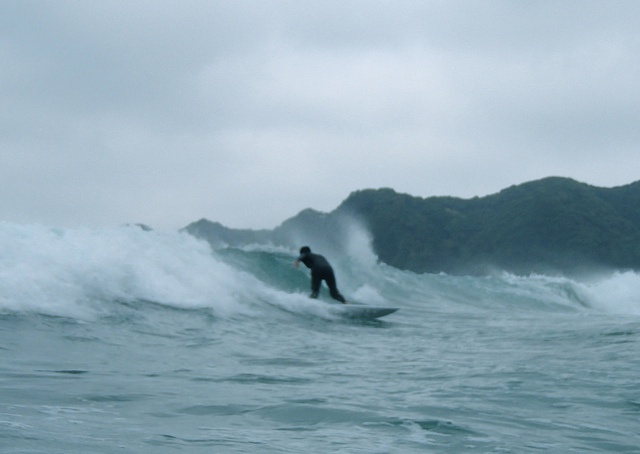Describe the objects in this image and their specific colors. I can see people in lightblue, black, blue, gray, and darkblue tones and surfboard in lightblue, blue, gray, and teal tones in this image. 